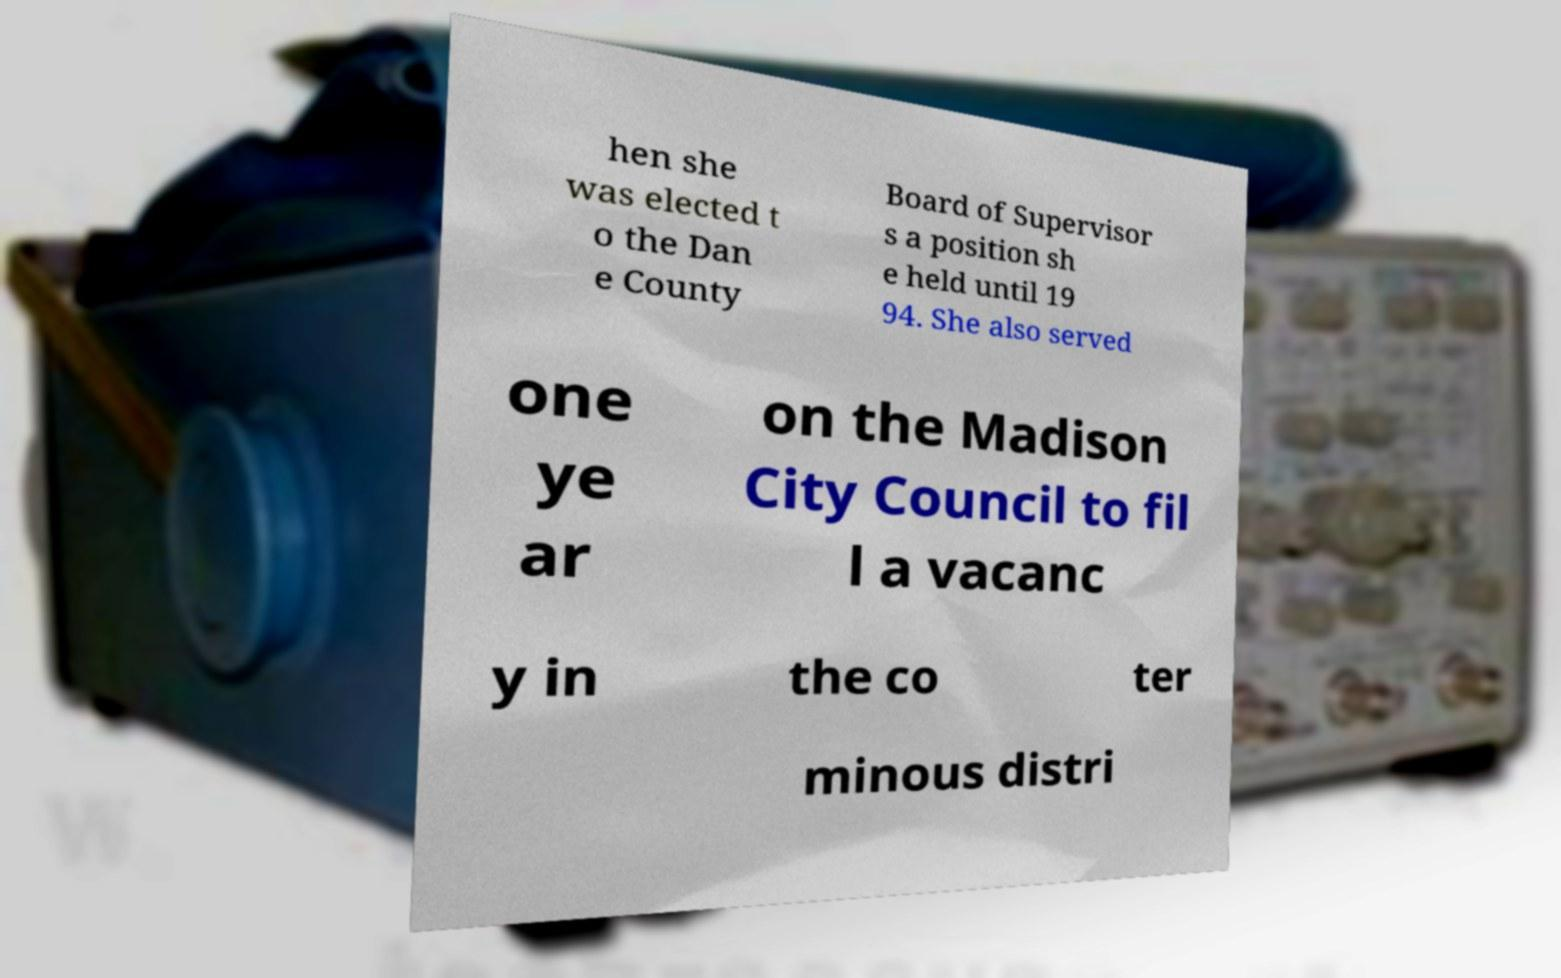Could you assist in decoding the text presented in this image and type it out clearly? hen she was elected t o the Dan e County Board of Supervisor s a position sh e held until 19 94. She also served one ye ar on the Madison City Council to fil l a vacanc y in the co ter minous distri 